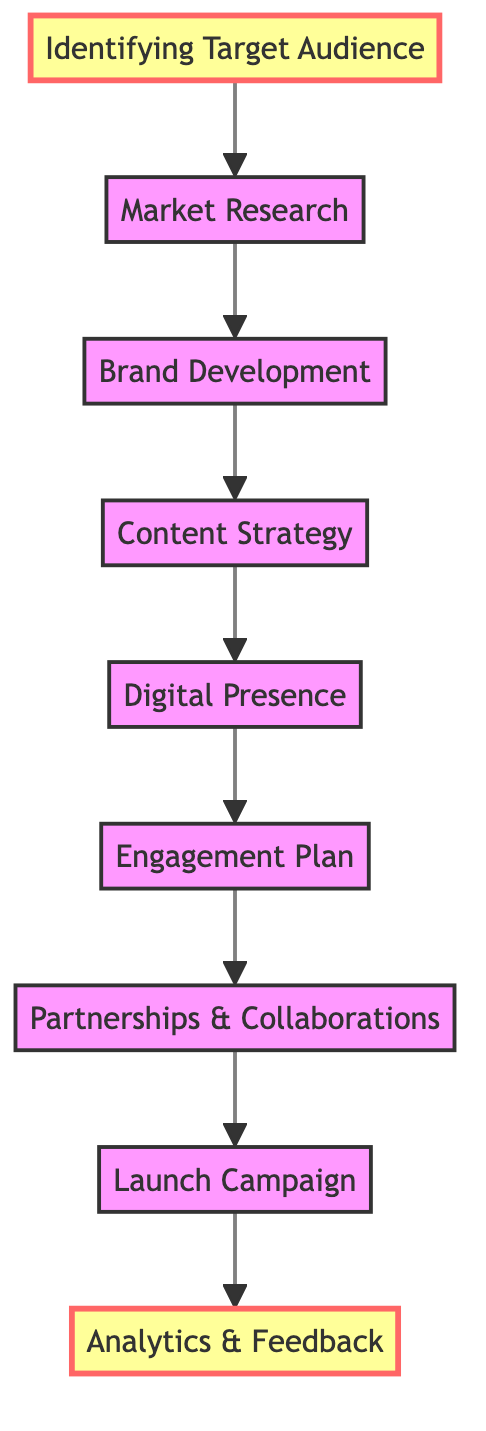What is the first step in the marketing strategy? The first step is "Identifying Target Audience", as it is the initial node in the flowchart and does not depend on any prior steps.
Answer: Identifying Target Audience How many total steps are in the flowchart? By counting the nodes from the flowchart, there are nine distinct steps represented.
Answer: 9 Which step follows "Digital Presence"? "Engagement Plan" comes directly after "Digital Presence" in the flowchart, indicated by the connecting arrow.
Answer: Engagement Plan What is the last step of the marketing strategy? The last step in the flowchart is "Analytics & Feedback", as it follows all other processes and is the terminal node.
Answer: Analytics & Feedback What is the relationship between "Market Research" and "Identifying Target Audience"? "Market Research" directly depends on "Identifying Target Audience" as indicated by a downstream arrow in the flow, meaning it can only occur after identifying the target audience.
Answer: Depends What is the role of "Partnerships & Collaborations" in the strategy? It serves as a crucial step that follows the "Engagement Plan" and is essential for expanding the artist’s reach before executing the next step, "Launch Campaign".
Answer: Expand reach Which node connects "Brand Development" and "Content Strategy"? There is a direct arrow connecting "Brand Development" to "Content Strategy", indicating that "Content Strategy" is dependent on the completion of "Brand Development".
Answer: Content Strategy How many dependencies does the step "Launch Campaign" have? "Launch Campaign" has one dependency which is "Partnerships & Collaborations", as it must occur after securing partnerships.
Answer: 1 What is the main focus of the "Engagement Plan"? The main focus is to develop strategies for interacting with fans through various channels, established after creating a digital presence.
Answer: Fan interaction 